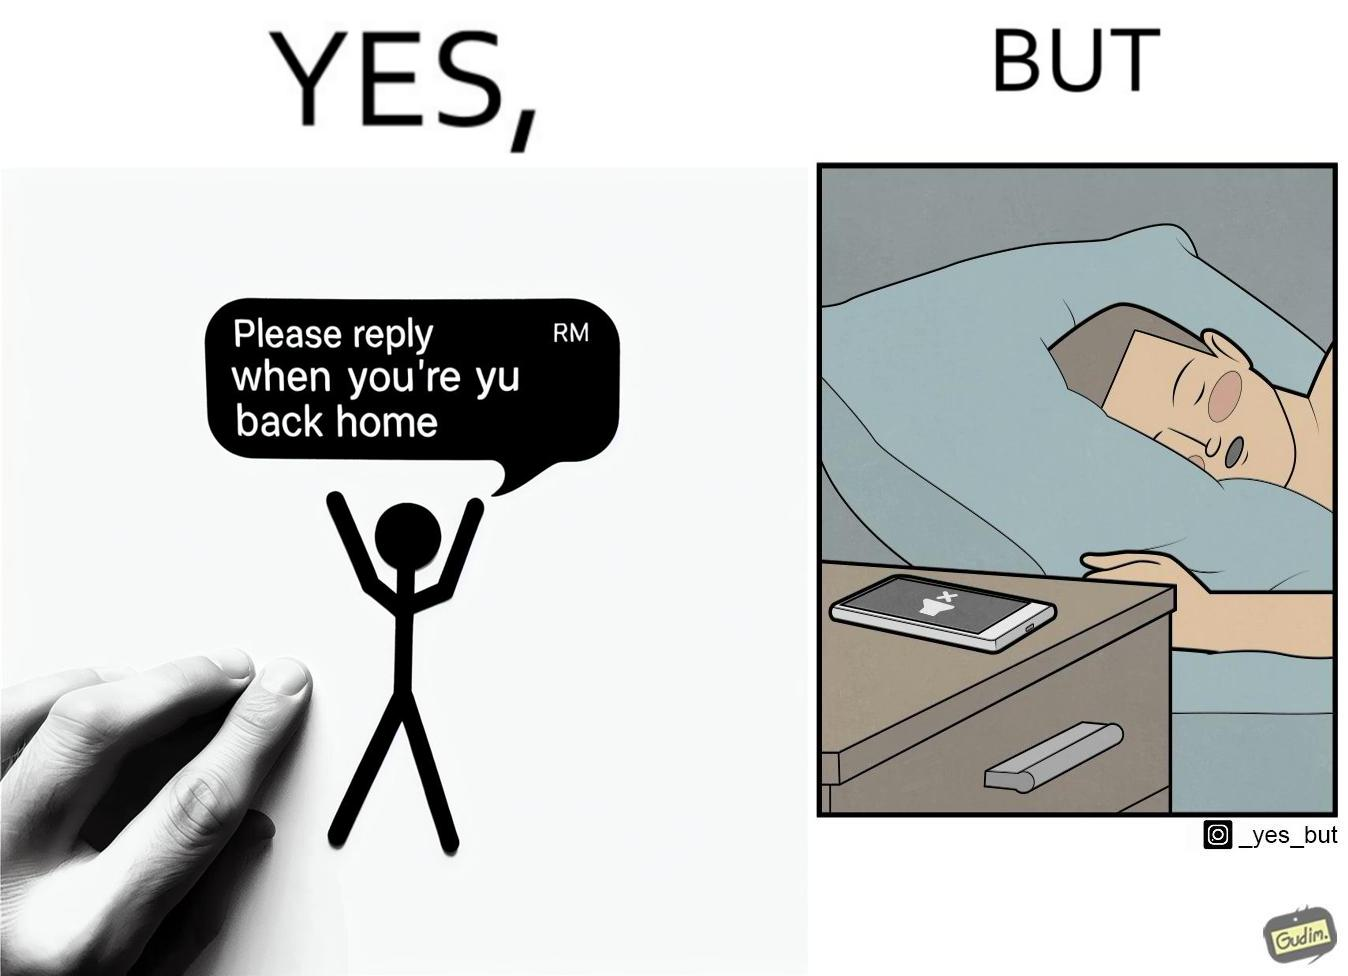Is there satirical content in this image? Yes, this image is satirical. 